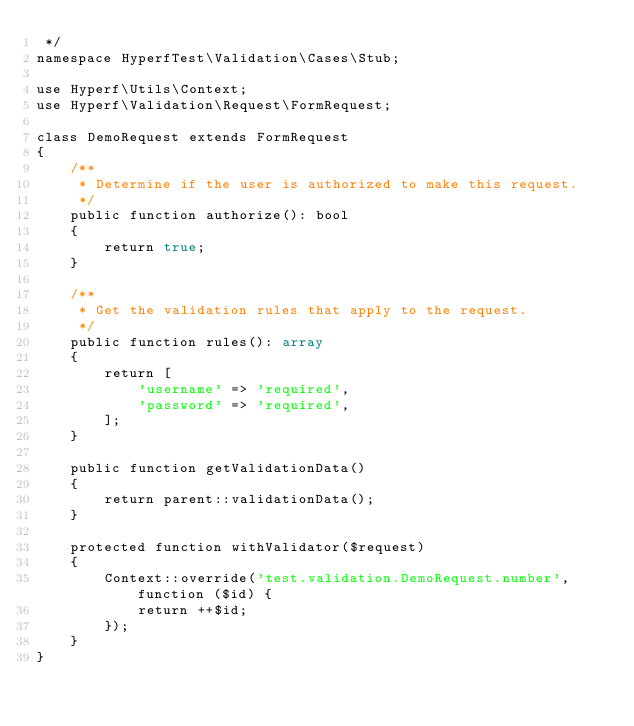<code> <loc_0><loc_0><loc_500><loc_500><_PHP_> */
namespace HyperfTest\Validation\Cases\Stub;

use Hyperf\Utils\Context;
use Hyperf\Validation\Request\FormRequest;

class DemoRequest extends FormRequest
{
    /**
     * Determine if the user is authorized to make this request.
     */
    public function authorize(): bool
    {
        return true;
    }

    /**
     * Get the validation rules that apply to the request.
     */
    public function rules(): array
    {
        return [
            'username' => 'required',
            'password' => 'required',
        ];
    }

    public function getValidationData()
    {
        return parent::validationData();
    }

    protected function withValidator($request)
    {
        Context::override('test.validation.DemoRequest.number', function ($id) {
            return ++$id;
        });
    }
}
</code> 